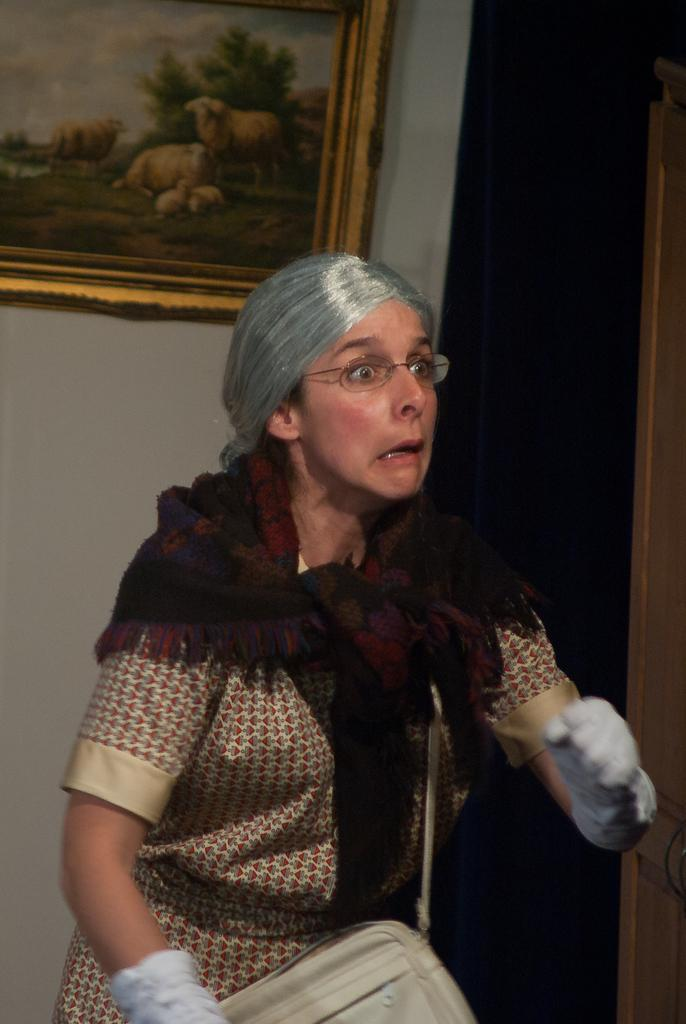Who is present in the image? There is a person in the image. What is the person wearing? The person is wearing clothes. What is the person holding or carrying? The person is carrying a bag. What can be seen on the wall in the image? There is a photo frame on the wall in the image. What color is the crayon being used by the person in the image? There is no crayon present in the image. How many threads are visible on the person's clothing in the image? The provided facts do not mention the number of threads on the person's clothing, so it cannot be determined from the image. 